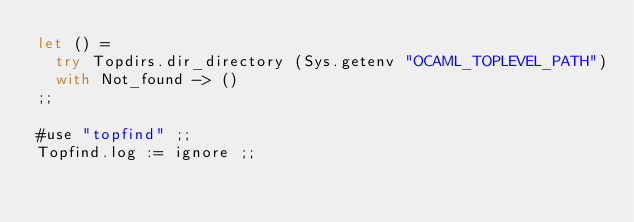Convert code to text. <code><loc_0><loc_0><loc_500><loc_500><_OCaml_>let () =
  try Topdirs.dir_directory (Sys.getenv "OCAML_TOPLEVEL_PATH")
  with Not_found -> ()
;;

#use "topfind" ;;
Topfind.log := ignore ;;
</code> 